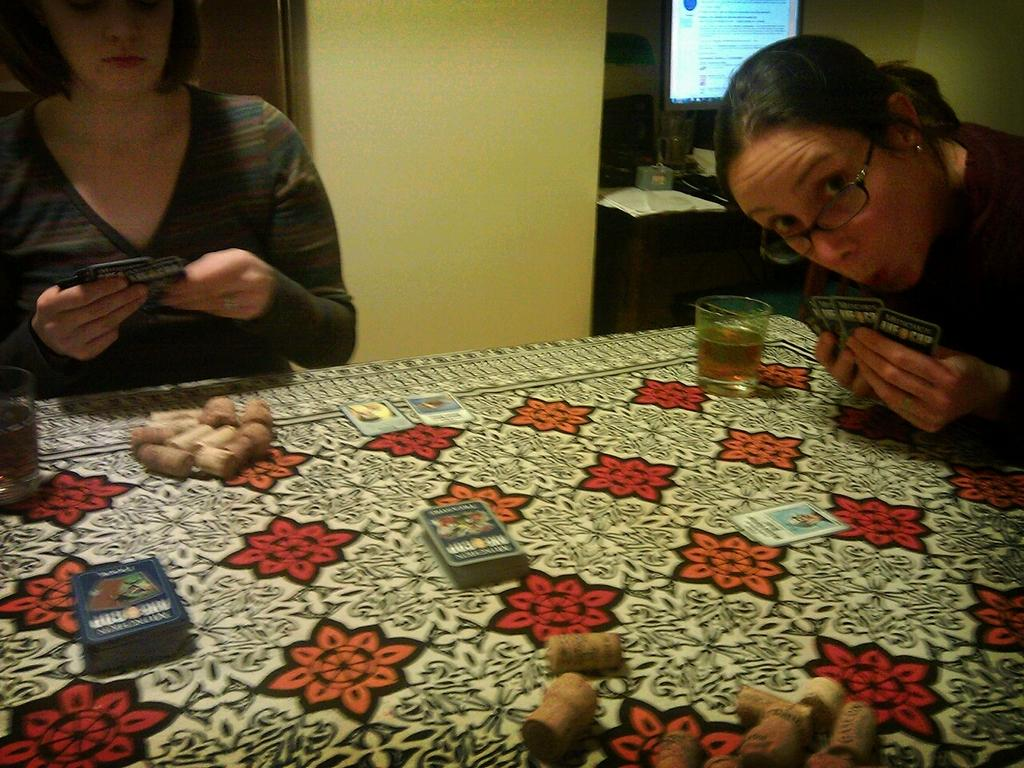How many women are in the image? There are two women in the image. What are the women holding in the image? The women are holding cards. Can you describe one of the women's appearance? One of the women is wearing glasses. What else can be seen on the table in the image? There are glasses and more cards on the table. What type of invention can be seen on the table in the image? There is no invention present on the table in the image. Can you tell me how many mittens are visible in the image? There are no mittens visible in the image. 